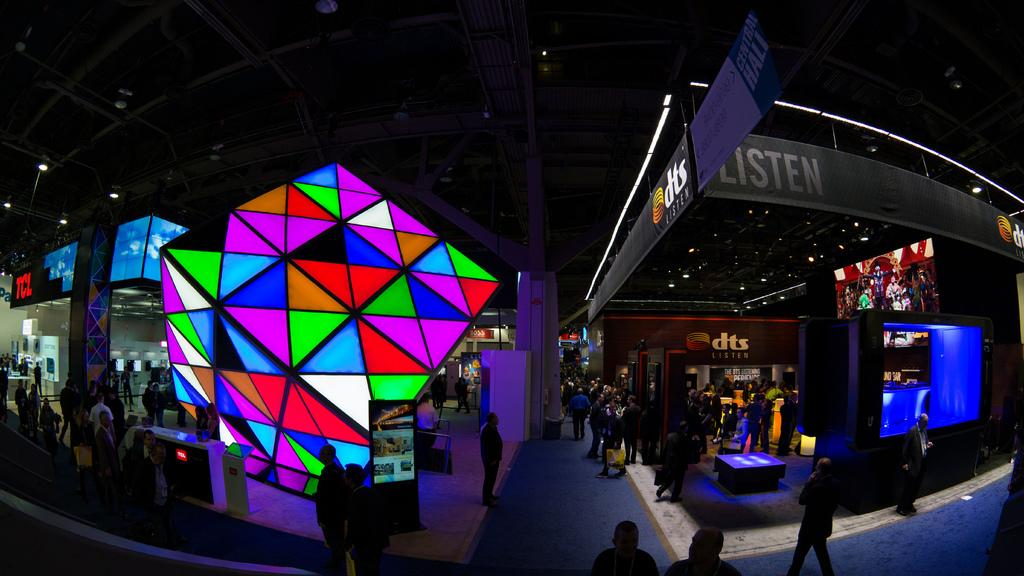What type of scene is depicted in the image? The image is a wide angle view of an event. Can you describe the people in the image? There is a huge crowd in the image. What other objects can be seen in the image besides the crowd? There are posters and LED screens displaying pictures in the image. What type of weather can be seen in the image? The provided facts do not mention any weather conditions, so it cannot be determined from the image. Is the event taking place during the night in the image? The provided facts do not mention the time of day, so it cannot be determined from the image. 